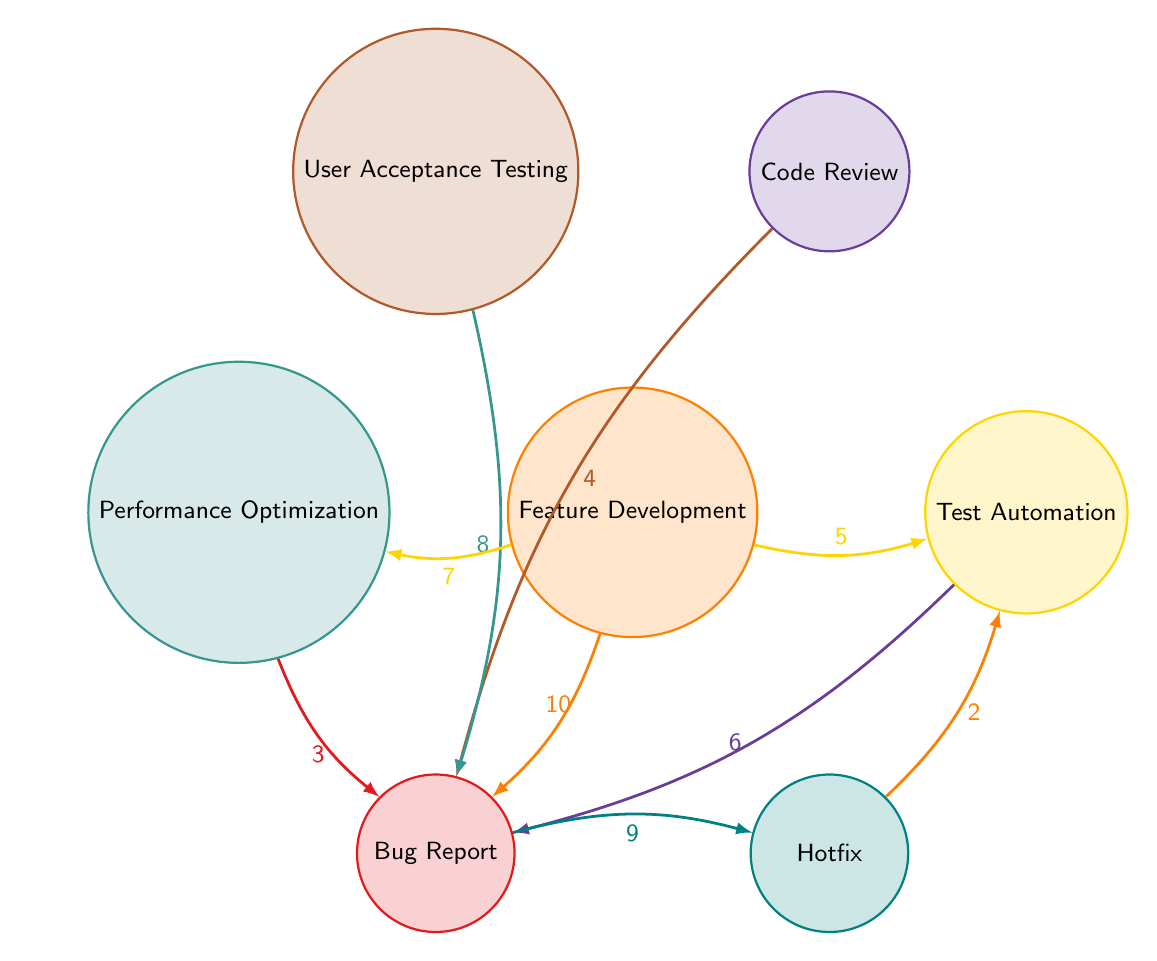What is the value of the connection between Feature Development and Bug Report? The diagram shows a direct connection from Feature Development to Bug Report with a value of 10 indicated on the arrow.
Answer: 10 What node has the second-highest connection value to Bug Report? The connection values to Bug Report are 10 from Feature Development, 8 from User Acceptance Testing, 6 from Test Automation, 4 from Code Review, and 3 from Performance Optimization. The second-highest value is 8 from User Acceptance Testing.
Answer: 8 How many connections are there to Bug Report? By examining the outgoing links towards Bug Report, we can see that there are five distinct nodes (Feature Development, Test Automation, Code Review, User Acceptance Testing, Performance Optimization) that connect to it, leading to a total of five connections.
Answer: 5 Which feature has a direct impact on both Bug Report and Performance Optimization? The only feature that links directly to both Bug Report and Performance Optimization is Feature Development, as it connects to Bug Report with a value of 10 and also connects to Performance Optimization with a value of 7.
Answer: Feature Development What is the total value of links directed towards Bug Report? Adding the values from each node connecting to Bug Report: 10 (Feature Development) + 6 (Test Automation) + 4 (Code Review) + 8 (User Acceptance Testing) + 3 (Performance Optimization) gives us a total of 31 for links towards Bug Report.
Answer: 31 How does Bug Report connect to Hotfix, and what is the value? In the diagram, Bug Report has a connection to Hotfix that is clearly marked with a value of 9 directed from Bug Report to Hotfix, indicating the transfer of issues reported as bugs into fixes.
Answer: 9 What is the value of the connection from Hotfix to Test Automation? The arrow linking Hotfix to Test Automation shows a value of 2. This indicates a relatively lower impact of hotfixes on test automation efforts compared to other features.
Answer: 2 Which node has the least connections pointing toward Bug Report? By reviewing the connections to Bug Report, the node Performance Optimization has the least number of issues reported with a value of 3, indicating its lower influence on bug reporting during the release cycle.
Answer: Performance Optimization What does the connection from Feature Development to Performance Optimization indicate? The link from Feature Development to Performance Optimization is marked with a value of 7, suggesting that as new features are developed, they simultaneously lead to a significant effort in optimizing performance.
Answer: 7 